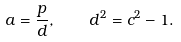<formula> <loc_0><loc_0><loc_500><loc_500>a = \frac { p } { d } , \quad d ^ { 2 } = c ^ { 2 } - 1 .</formula> 